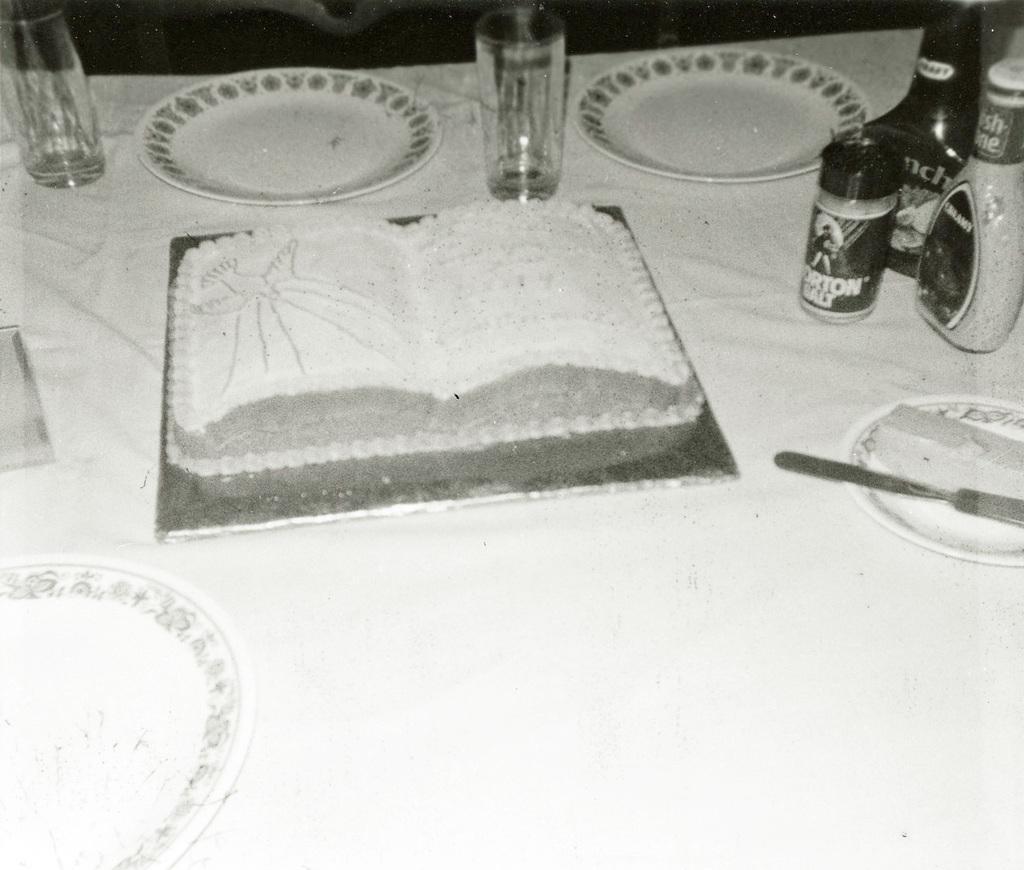How would you summarize this image in a sentence or two? In this image we can see plates, glasses and some other objects placed on the white surface. 